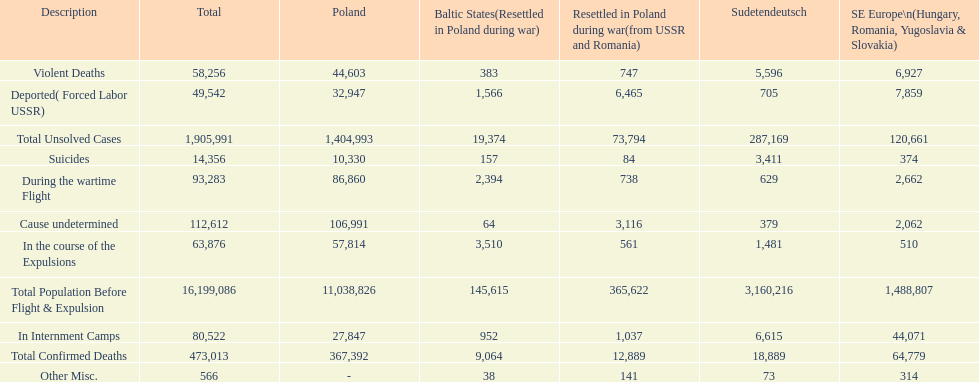How many causes were responsible for more than 50,000 confirmed deaths? 5. 